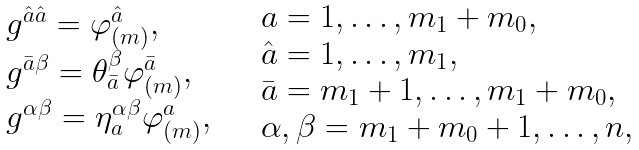Convert formula to latex. <formula><loc_0><loc_0><loc_500><loc_500>\begin{array} { l } g ^ { \hat { a } \hat { a } } = \varphi ^ { \hat { a } } _ { ( m ) } , \\ g ^ { \bar { a } \beta } = \theta ^ { \beta } _ { \bar { a } } \varphi ^ { \bar { a } } _ { ( m ) } , \\ g ^ { \alpha \beta } = \eta ^ { \alpha \beta } _ { a } \varphi ^ { a } _ { ( m ) } , \end{array} \quad \begin{array} { l } a = 1 , \dots , m _ { 1 } + m _ { 0 } , \\ \hat { a } = 1 , \dots , m _ { 1 } , \\ \bar { a } = m _ { 1 } + 1 , \dots , m _ { 1 } + m _ { 0 } , \\ \alpha , \beta = m _ { 1 } + m _ { 0 } + 1 , \dots , n , \end{array}</formula> 